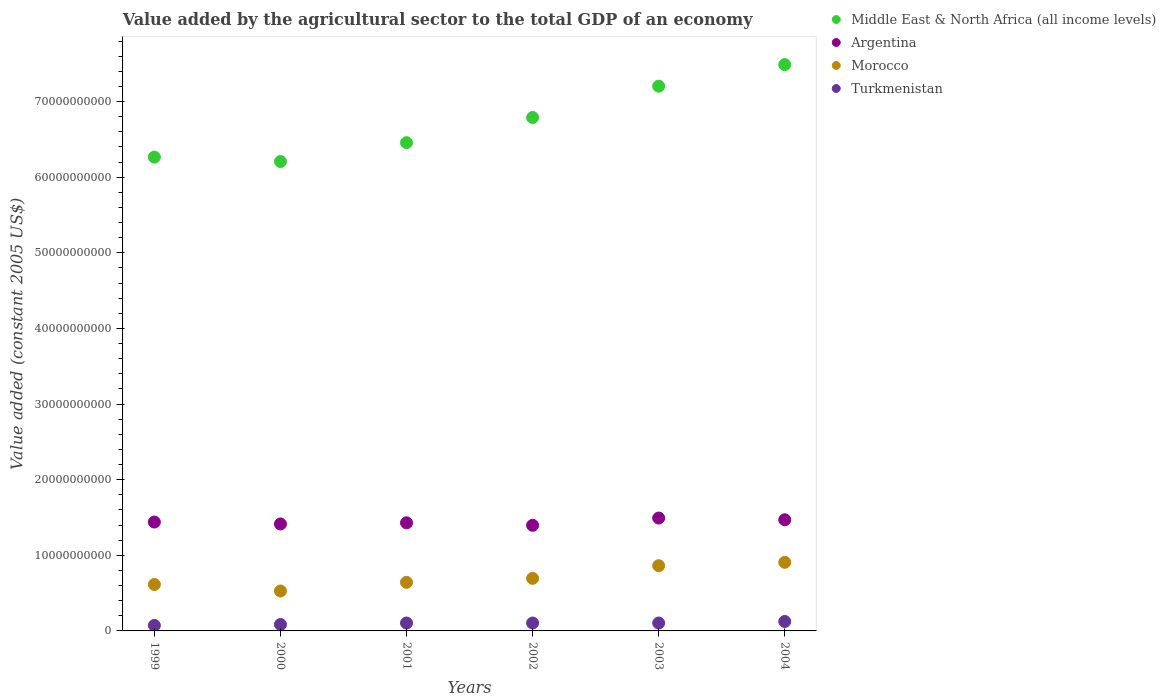Is the number of dotlines equal to the number of legend labels?
Offer a terse response. Yes. What is the value added by the agricultural sector in Morocco in 2003?
Keep it short and to the point. 8.62e+09. Across all years, what is the maximum value added by the agricultural sector in Middle East & North Africa (all income levels)?
Offer a very short reply. 7.49e+1. Across all years, what is the minimum value added by the agricultural sector in Turkmenistan?
Make the answer very short. 7.26e+08. In which year was the value added by the agricultural sector in Middle East & North Africa (all income levels) maximum?
Offer a very short reply. 2004. What is the total value added by the agricultural sector in Argentina in the graph?
Offer a very short reply. 8.64e+1. What is the difference between the value added by the agricultural sector in Turkmenistan in 1999 and that in 2000?
Your answer should be very brief. -1.23e+08. What is the difference between the value added by the agricultural sector in Morocco in 2002 and the value added by the agricultural sector in Turkmenistan in 1999?
Your response must be concise. 6.22e+09. What is the average value added by the agricultural sector in Turkmenistan per year?
Keep it short and to the point. 9.93e+08. In the year 2000, what is the difference between the value added by the agricultural sector in Turkmenistan and value added by the agricultural sector in Morocco?
Provide a succinct answer. -4.43e+09. In how many years, is the value added by the agricultural sector in Middle East & North Africa (all income levels) greater than 68000000000 US$?
Offer a very short reply. 2. What is the ratio of the value added by the agricultural sector in Morocco in 2000 to that in 2003?
Provide a succinct answer. 0.61. Is the value added by the agricultural sector in Argentina in 2000 less than that in 2004?
Your answer should be very brief. Yes. What is the difference between the highest and the second highest value added by the agricultural sector in Argentina?
Give a very brief answer. 2.28e+08. What is the difference between the highest and the lowest value added by the agricultural sector in Morocco?
Offer a terse response. 3.79e+09. In how many years, is the value added by the agricultural sector in Turkmenistan greater than the average value added by the agricultural sector in Turkmenistan taken over all years?
Your answer should be compact. 4. Is it the case that in every year, the sum of the value added by the agricultural sector in Middle East & North Africa (all income levels) and value added by the agricultural sector in Argentina  is greater than the value added by the agricultural sector in Turkmenistan?
Keep it short and to the point. Yes. Does the value added by the agricultural sector in Morocco monotonically increase over the years?
Offer a terse response. No. Is the value added by the agricultural sector in Argentina strictly less than the value added by the agricultural sector in Turkmenistan over the years?
Give a very brief answer. No. How many years are there in the graph?
Offer a very short reply. 6. Does the graph contain grids?
Keep it short and to the point. No. How are the legend labels stacked?
Offer a terse response. Vertical. What is the title of the graph?
Give a very brief answer. Value added by the agricultural sector to the total GDP of an economy. What is the label or title of the Y-axis?
Your answer should be compact. Value added (constant 2005 US$). What is the Value added (constant 2005 US$) in Middle East & North Africa (all income levels) in 1999?
Ensure brevity in your answer.  6.26e+1. What is the Value added (constant 2005 US$) in Argentina in 1999?
Provide a succinct answer. 1.44e+1. What is the Value added (constant 2005 US$) of Morocco in 1999?
Offer a terse response. 6.14e+09. What is the Value added (constant 2005 US$) of Turkmenistan in 1999?
Offer a very short reply. 7.26e+08. What is the Value added (constant 2005 US$) of Middle East & North Africa (all income levels) in 2000?
Provide a short and direct response. 6.21e+1. What is the Value added (constant 2005 US$) of Argentina in 2000?
Keep it short and to the point. 1.41e+1. What is the Value added (constant 2005 US$) in Morocco in 2000?
Keep it short and to the point. 5.28e+09. What is the Value added (constant 2005 US$) of Turkmenistan in 2000?
Make the answer very short. 8.49e+08. What is the Value added (constant 2005 US$) of Middle East & North Africa (all income levels) in 2001?
Give a very brief answer. 6.46e+1. What is the Value added (constant 2005 US$) of Argentina in 2001?
Keep it short and to the point. 1.43e+1. What is the Value added (constant 2005 US$) of Morocco in 2001?
Ensure brevity in your answer.  6.42e+09. What is the Value added (constant 2005 US$) of Turkmenistan in 2001?
Offer a very short reply. 1.04e+09. What is the Value added (constant 2005 US$) of Middle East & North Africa (all income levels) in 2002?
Provide a succinct answer. 6.79e+1. What is the Value added (constant 2005 US$) in Argentina in 2002?
Ensure brevity in your answer.  1.40e+1. What is the Value added (constant 2005 US$) of Morocco in 2002?
Offer a terse response. 6.95e+09. What is the Value added (constant 2005 US$) in Turkmenistan in 2002?
Your response must be concise. 1.05e+09. What is the Value added (constant 2005 US$) of Middle East & North Africa (all income levels) in 2003?
Your answer should be compact. 7.20e+1. What is the Value added (constant 2005 US$) in Argentina in 2003?
Keep it short and to the point. 1.49e+1. What is the Value added (constant 2005 US$) in Morocco in 2003?
Your answer should be very brief. 8.62e+09. What is the Value added (constant 2005 US$) in Turkmenistan in 2003?
Offer a very short reply. 1.05e+09. What is the Value added (constant 2005 US$) in Middle East & North Africa (all income levels) in 2004?
Offer a terse response. 7.49e+1. What is the Value added (constant 2005 US$) in Argentina in 2004?
Ensure brevity in your answer.  1.47e+1. What is the Value added (constant 2005 US$) in Morocco in 2004?
Provide a short and direct response. 9.07e+09. What is the Value added (constant 2005 US$) of Turkmenistan in 2004?
Make the answer very short. 1.25e+09. Across all years, what is the maximum Value added (constant 2005 US$) in Middle East & North Africa (all income levels)?
Provide a short and direct response. 7.49e+1. Across all years, what is the maximum Value added (constant 2005 US$) in Argentina?
Your response must be concise. 1.49e+1. Across all years, what is the maximum Value added (constant 2005 US$) in Morocco?
Offer a terse response. 9.07e+09. Across all years, what is the maximum Value added (constant 2005 US$) of Turkmenistan?
Offer a very short reply. 1.25e+09. Across all years, what is the minimum Value added (constant 2005 US$) in Middle East & North Africa (all income levels)?
Your answer should be compact. 6.21e+1. Across all years, what is the minimum Value added (constant 2005 US$) in Argentina?
Offer a very short reply. 1.40e+1. Across all years, what is the minimum Value added (constant 2005 US$) of Morocco?
Give a very brief answer. 5.28e+09. Across all years, what is the minimum Value added (constant 2005 US$) of Turkmenistan?
Your answer should be compact. 7.26e+08. What is the total Value added (constant 2005 US$) in Middle East & North Africa (all income levels) in the graph?
Provide a short and direct response. 4.04e+11. What is the total Value added (constant 2005 US$) in Argentina in the graph?
Offer a terse response. 8.64e+1. What is the total Value added (constant 2005 US$) in Morocco in the graph?
Your answer should be compact. 4.25e+1. What is the total Value added (constant 2005 US$) in Turkmenistan in the graph?
Keep it short and to the point. 5.96e+09. What is the difference between the Value added (constant 2005 US$) of Middle East & North Africa (all income levels) in 1999 and that in 2000?
Provide a succinct answer. 5.78e+08. What is the difference between the Value added (constant 2005 US$) in Argentina in 1999 and that in 2000?
Provide a short and direct response. 2.53e+08. What is the difference between the Value added (constant 2005 US$) in Morocco in 1999 and that in 2000?
Your answer should be very brief. 8.59e+08. What is the difference between the Value added (constant 2005 US$) in Turkmenistan in 1999 and that in 2000?
Provide a short and direct response. -1.23e+08. What is the difference between the Value added (constant 2005 US$) in Middle East & North Africa (all income levels) in 1999 and that in 2001?
Your response must be concise. -1.91e+09. What is the difference between the Value added (constant 2005 US$) of Argentina in 1999 and that in 2001?
Offer a very short reply. 1.04e+08. What is the difference between the Value added (constant 2005 US$) in Morocco in 1999 and that in 2001?
Make the answer very short. -2.87e+08. What is the difference between the Value added (constant 2005 US$) of Turkmenistan in 1999 and that in 2001?
Your response must be concise. -3.19e+08. What is the difference between the Value added (constant 2005 US$) of Middle East & North Africa (all income levels) in 1999 and that in 2002?
Your answer should be compact. -5.24e+09. What is the difference between the Value added (constant 2005 US$) in Argentina in 1999 and that in 2002?
Keep it short and to the point. 4.30e+08. What is the difference between the Value added (constant 2005 US$) in Morocco in 1999 and that in 2002?
Your answer should be compact. -8.09e+08. What is the difference between the Value added (constant 2005 US$) of Turkmenistan in 1999 and that in 2002?
Provide a succinct answer. -3.20e+08. What is the difference between the Value added (constant 2005 US$) of Middle East & North Africa (all income levels) in 1999 and that in 2003?
Provide a short and direct response. -9.38e+09. What is the difference between the Value added (constant 2005 US$) in Argentina in 1999 and that in 2003?
Provide a succinct answer. -5.29e+08. What is the difference between the Value added (constant 2005 US$) of Morocco in 1999 and that in 2003?
Ensure brevity in your answer.  -2.48e+09. What is the difference between the Value added (constant 2005 US$) of Turkmenistan in 1999 and that in 2003?
Ensure brevity in your answer.  -3.21e+08. What is the difference between the Value added (constant 2005 US$) of Middle East & North Africa (all income levels) in 1999 and that in 2004?
Give a very brief answer. -1.22e+1. What is the difference between the Value added (constant 2005 US$) of Argentina in 1999 and that in 2004?
Keep it short and to the point. -3.01e+08. What is the difference between the Value added (constant 2005 US$) in Morocco in 1999 and that in 2004?
Offer a terse response. -2.93e+09. What is the difference between the Value added (constant 2005 US$) of Turkmenistan in 1999 and that in 2004?
Ensure brevity in your answer.  -5.23e+08. What is the difference between the Value added (constant 2005 US$) of Middle East & North Africa (all income levels) in 2000 and that in 2001?
Your answer should be compact. -2.49e+09. What is the difference between the Value added (constant 2005 US$) in Argentina in 2000 and that in 2001?
Provide a succinct answer. -1.49e+08. What is the difference between the Value added (constant 2005 US$) of Morocco in 2000 and that in 2001?
Your answer should be very brief. -1.15e+09. What is the difference between the Value added (constant 2005 US$) of Turkmenistan in 2000 and that in 2001?
Give a very brief answer. -1.95e+08. What is the difference between the Value added (constant 2005 US$) of Middle East & North Africa (all income levels) in 2000 and that in 2002?
Provide a short and direct response. -5.82e+09. What is the difference between the Value added (constant 2005 US$) of Argentina in 2000 and that in 2002?
Give a very brief answer. 1.78e+08. What is the difference between the Value added (constant 2005 US$) in Morocco in 2000 and that in 2002?
Provide a succinct answer. -1.67e+09. What is the difference between the Value added (constant 2005 US$) in Turkmenistan in 2000 and that in 2002?
Offer a terse response. -1.96e+08. What is the difference between the Value added (constant 2005 US$) of Middle East & North Africa (all income levels) in 2000 and that in 2003?
Offer a very short reply. -9.96e+09. What is the difference between the Value added (constant 2005 US$) of Argentina in 2000 and that in 2003?
Keep it short and to the point. -7.82e+08. What is the difference between the Value added (constant 2005 US$) in Morocco in 2000 and that in 2003?
Provide a succinct answer. -3.34e+09. What is the difference between the Value added (constant 2005 US$) of Turkmenistan in 2000 and that in 2003?
Your response must be concise. -1.97e+08. What is the difference between the Value added (constant 2005 US$) of Middle East & North Africa (all income levels) in 2000 and that in 2004?
Offer a very short reply. -1.28e+1. What is the difference between the Value added (constant 2005 US$) in Argentina in 2000 and that in 2004?
Offer a very short reply. -5.54e+08. What is the difference between the Value added (constant 2005 US$) of Morocco in 2000 and that in 2004?
Your answer should be very brief. -3.79e+09. What is the difference between the Value added (constant 2005 US$) in Turkmenistan in 2000 and that in 2004?
Your answer should be compact. -3.99e+08. What is the difference between the Value added (constant 2005 US$) in Middle East & North Africa (all income levels) in 2001 and that in 2002?
Provide a succinct answer. -3.33e+09. What is the difference between the Value added (constant 2005 US$) of Argentina in 2001 and that in 2002?
Ensure brevity in your answer.  3.27e+08. What is the difference between the Value added (constant 2005 US$) of Morocco in 2001 and that in 2002?
Your response must be concise. -5.23e+08. What is the difference between the Value added (constant 2005 US$) of Turkmenistan in 2001 and that in 2002?
Provide a short and direct response. -9.92e+05. What is the difference between the Value added (constant 2005 US$) in Middle East & North Africa (all income levels) in 2001 and that in 2003?
Offer a terse response. -7.47e+09. What is the difference between the Value added (constant 2005 US$) in Argentina in 2001 and that in 2003?
Offer a very short reply. -6.33e+08. What is the difference between the Value added (constant 2005 US$) in Morocco in 2001 and that in 2003?
Your answer should be very brief. -2.20e+09. What is the difference between the Value added (constant 2005 US$) in Turkmenistan in 2001 and that in 2003?
Make the answer very short. -2.03e+06. What is the difference between the Value added (constant 2005 US$) of Middle East & North Africa (all income levels) in 2001 and that in 2004?
Provide a short and direct response. -1.03e+1. What is the difference between the Value added (constant 2005 US$) in Argentina in 2001 and that in 2004?
Keep it short and to the point. -4.05e+08. What is the difference between the Value added (constant 2005 US$) of Morocco in 2001 and that in 2004?
Provide a short and direct response. -2.65e+09. What is the difference between the Value added (constant 2005 US$) in Turkmenistan in 2001 and that in 2004?
Keep it short and to the point. -2.04e+08. What is the difference between the Value added (constant 2005 US$) of Middle East & North Africa (all income levels) in 2002 and that in 2003?
Keep it short and to the point. -4.14e+09. What is the difference between the Value added (constant 2005 US$) in Argentina in 2002 and that in 2003?
Give a very brief answer. -9.60e+08. What is the difference between the Value added (constant 2005 US$) in Morocco in 2002 and that in 2003?
Keep it short and to the point. -1.67e+09. What is the difference between the Value added (constant 2005 US$) of Turkmenistan in 2002 and that in 2003?
Provide a succinct answer. -1.03e+06. What is the difference between the Value added (constant 2005 US$) in Middle East & North Africa (all income levels) in 2002 and that in 2004?
Provide a short and direct response. -6.99e+09. What is the difference between the Value added (constant 2005 US$) of Argentina in 2002 and that in 2004?
Ensure brevity in your answer.  -7.32e+08. What is the difference between the Value added (constant 2005 US$) in Morocco in 2002 and that in 2004?
Offer a very short reply. -2.12e+09. What is the difference between the Value added (constant 2005 US$) in Turkmenistan in 2002 and that in 2004?
Your response must be concise. -2.03e+08. What is the difference between the Value added (constant 2005 US$) in Middle East & North Africa (all income levels) in 2003 and that in 2004?
Ensure brevity in your answer.  -2.85e+09. What is the difference between the Value added (constant 2005 US$) of Argentina in 2003 and that in 2004?
Your answer should be very brief. 2.28e+08. What is the difference between the Value added (constant 2005 US$) in Morocco in 2003 and that in 2004?
Provide a succinct answer. -4.49e+08. What is the difference between the Value added (constant 2005 US$) in Turkmenistan in 2003 and that in 2004?
Offer a very short reply. -2.02e+08. What is the difference between the Value added (constant 2005 US$) of Middle East & North Africa (all income levels) in 1999 and the Value added (constant 2005 US$) of Argentina in 2000?
Provide a succinct answer. 4.85e+1. What is the difference between the Value added (constant 2005 US$) of Middle East & North Africa (all income levels) in 1999 and the Value added (constant 2005 US$) of Morocco in 2000?
Keep it short and to the point. 5.74e+1. What is the difference between the Value added (constant 2005 US$) in Middle East & North Africa (all income levels) in 1999 and the Value added (constant 2005 US$) in Turkmenistan in 2000?
Your response must be concise. 6.18e+1. What is the difference between the Value added (constant 2005 US$) of Argentina in 1999 and the Value added (constant 2005 US$) of Morocco in 2000?
Ensure brevity in your answer.  9.12e+09. What is the difference between the Value added (constant 2005 US$) of Argentina in 1999 and the Value added (constant 2005 US$) of Turkmenistan in 2000?
Provide a succinct answer. 1.35e+1. What is the difference between the Value added (constant 2005 US$) of Morocco in 1999 and the Value added (constant 2005 US$) of Turkmenistan in 2000?
Provide a short and direct response. 5.29e+09. What is the difference between the Value added (constant 2005 US$) of Middle East & North Africa (all income levels) in 1999 and the Value added (constant 2005 US$) of Argentina in 2001?
Your answer should be very brief. 4.84e+1. What is the difference between the Value added (constant 2005 US$) of Middle East & North Africa (all income levels) in 1999 and the Value added (constant 2005 US$) of Morocco in 2001?
Offer a very short reply. 5.62e+1. What is the difference between the Value added (constant 2005 US$) in Middle East & North Africa (all income levels) in 1999 and the Value added (constant 2005 US$) in Turkmenistan in 2001?
Provide a succinct answer. 6.16e+1. What is the difference between the Value added (constant 2005 US$) of Argentina in 1999 and the Value added (constant 2005 US$) of Morocco in 2001?
Offer a terse response. 7.97e+09. What is the difference between the Value added (constant 2005 US$) in Argentina in 1999 and the Value added (constant 2005 US$) in Turkmenistan in 2001?
Your answer should be compact. 1.34e+1. What is the difference between the Value added (constant 2005 US$) of Morocco in 1999 and the Value added (constant 2005 US$) of Turkmenistan in 2001?
Offer a very short reply. 5.09e+09. What is the difference between the Value added (constant 2005 US$) of Middle East & North Africa (all income levels) in 1999 and the Value added (constant 2005 US$) of Argentina in 2002?
Your answer should be compact. 4.87e+1. What is the difference between the Value added (constant 2005 US$) in Middle East & North Africa (all income levels) in 1999 and the Value added (constant 2005 US$) in Morocco in 2002?
Your answer should be very brief. 5.57e+1. What is the difference between the Value added (constant 2005 US$) in Middle East & North Africa (all income levels) in 1999 and the Value added (constant 2005 US$) in Turkmenistan in 2002?
Your answer should be very brief. 6.16e+1. What is the difference between the Value added (constant 2005 US$) of Argentina in 1999 and the Value added (constant 2005 US$) of Morocco in 2002?
Give a very brief answer. 7.45e+09. What is the difference between the Value added (constant 2005 US$) of Argentina in 1999 and the Value added (constant 2005 US$) of Turkmenistan in 2002?
Provide a succinct answer. 1.34e+1. What is the difference between the Value added (constant 2005 US$) of Morocco in 1999 and the Value added (constant 2005 US$) of Turkmenistan in 2002?
Give a very brief answer. 5.09e+09. What is the difference between the Value added (constant 2005 US$) in Middle East & North Africa (all income levels) in 1999 and the Value added (constant 2005 US$) in Argentina in 2003?
Give a very brief answer. 4.77e+1. What is the difference between the Value added (constant 2005 US$) in Middle East & North Africa (all income levels) in 1999 and the Value added (constant 2005 US$) in Morocco in 2003?
Provide a short and direct response. 5.40e+1. What is the difference between the Value added (constant 2005 US$) in Middle East & North Africa (all income levels) in 1999 and the Value added (constant 2005 US$) in Turkmenistan in 2003?
Make the answer very short. 6.16e+1. What is the difference between the Value added (constant 2005 US$) of Argentina in 1999 and the Value added (constant 2005 US$) of Morocco in 2003?
Provide a succinct answer. 5.78e+09. What is the difference between the Value added (constant 2005 US$) of Argentina in 1999 and the Value added (constant 2005 US$) of Turkmenistan in 2003?
Give a very brief answer. 1.34e+1. What is the difference between the Value added (constant 2005 US$) of Morocco in 1999 and the Value added (constant 2005 US$) of Turkmenistan in 2003?
Your answer should be compact. 5.09e+09. What is the difference between the Value added (constant 2005 US$) of Middle East & North Africa (all income levels) in 1999 and the Value added (constant 2005 US$) of Argentina in 2004?
Provide a succinct answer. 4.80e+1. What is the difference between the Value added (constant 2005 US$) of Middle East & North Africa (all income levels) in 1999 and the Value added (constant 2005 US$) of Morocco in 2004?
Make the answer very short. 5.36e+1. What is the difference between the Value added (constant 2005 US$) in Middle East & North Africa (all income levels) in 1999 and the Value added (constant 2005 US$) in Turkmenistan in 2004?
Your answer should be compact. 6.14e+1. What is the difference between the Value added (constant 2005 US$) in Argentina in 1999 and the Value added (constant 2005 US$) in Morocco in 2004?
Provide a short and direct response. 5.33e+09. What is the difference between the Value added (constant 2005 US$) of Argentina in 1999 and the Value added (constant 2005 US$) of Turkmenistan in 2004?
Make the answer very short. 1.31e+1. What is the difference between the Value added (constant 2005 US$) of Morocco in 1999 and the Value added (constant 2005 US$) of Turkmenistan in 2004?
Make the answer very short. 4.89e+09. What is the difference between the Value added (constant 2005 US$) of Middle East & North Africa (all income levels) in 2000 and the Value added (constant 2005 US$) of Argentina in 2001?
Your answer should be compact. 4.78e+1. What is the difference between the Value added (constant 2005 US$) of Middle East & North Africa (all income levels) in 2000 and the Value added (constant 2005 US$) of Morocco in 2001?
Provide a short and direct response. 5.56e+1. What is the difference between the Value added (constant 2005 US$) in Middle East & North Africa (all income levels) in 2000 and the Value added (constant 2005 US$) in Turkmenistan in 2001?
Make the answer very short. 6.10e+1. What is the difference between the Value added (constant 2005 US$) in Argentina in 2000 and the Value added (constant 2005 US$) in Morocco in 2001?
Ensure brevity in your answer.  7.72e+09. What is the difference between the Value added (constant 2005 US$) in Argentina in 2000 and the Value added (constant 2005 US$) in Turkmenistan in 2001?
Your answer should be very brief. 1.31e+1. What is the difference between the Value added (constant 2005 US$) in Morocco in 2000 and the Value added (constant 2005 US$) in Turkmenistan in 2001?
Make the answer very short. 4.23e+09. What is the difference between the Value added (constant 2005 US$) in Middle East & North Africa (all income levels) in 2000 and the Value added (constant 2005 US$) in Argentina in 2002?
Your answer should be very brief. 4.81e+1. What is the difference between the Value added (constant 2005 US$) in Middle East & North Africa (all income levels) in 2000 and the Value added (constant 2005 US$) in Morocco in 2002?
Offer a very short reply. 5.51e+1. What is the difference between the Value added (constant 2005 US$) in Middle East & North Africa (all income levels) in 2000 and the Value added (constant 2005 US$) in Turkmenistan in 2002?
Make the answer very short. 6.10e+1. What is the difference between the Value added (constant 2005 US$) of Argentina in 2000 and the Value added (constant 2005 US$) of Morocco in 2002?
Provide a short and direct response. 7.20e+09. What is the difference between the Value added (constant 2005 US$) of Argentina in 2000 and the Value added (constant 2005 US$) of Turkmenistan in 2002?
Provide a short and direct response. 1.31e+1. What is the difference between the Value added (constant 2005 US$) of Morocco in 2000 and the Value added (constant 2005 US$) of Turkmenistan in 2002?
Your response must be concise. 4.23e+09. What is the difference between the Value added (constant 2005 US$) of Middle East & North Africa (all income levels) in 2000 and the Value added (constant 2005 US$) of Argentina in 2003?
Make the answer very short. 4.71e+1. What is the difference between the Value added (constant 2005 US$) in Middle East & North Africa (all income levels) in 2000 and the Value added (constant 2005 US$) in Morocco in 2003?
Provide a succinct answer. 5.34e+1. What is the difference between the Value added (constant 2005 US$) of Middle East & North Africa (all income levels) in 2000 and the Value added (constant 2005 US$) of Turkmenistan in 2003?
Your answer should be compact. 6.10e+1. What is the difference between the Value added (constant 2005 US$) in Argentina in 2000 and the Value added (constant 2005 US$) in Morocco in 2003?
Your answer should be compact. 5.52e+09. What is the difference between the Value added (constant 2005 US$) in Argentina in 2000 and the Value added (constant 2005 US$) in Turkmenistan in 2003?
Your response must be concise. 1.31e+1. What is the difference between the Value added (constant 2005 US$) of Morocco in 2000 and the Value added (constant 2005 US$) of Turkmenistan in 2003?
Your answer should be compact. 4.23e+09. What is the difference between the Value added (constant 2005 US$) of Middle East & North Africa (all income levels) in 2000 and the Value added (constant 2005 US$) of Argentina in 2004?
Give a very brief answer. 4.74e+1. What is the difference between the Value added (constant 2005 US$) of Middle East & North Africa (all income levels) in 2000 and the Value added (constant 2005 US$) of Morocco in 2004?
Offer a very short reply. 5.30e+1. What is the difference between the Value added (constant 2005 US$) in Middle East & North Africa (all income levels) in 2000 and the Value added (constant 2005 US$) in Turkmenistan in 2004?
Keep it short and to the point. 6.08e+1. What is the difference between the Value added (constant 2005 US$) in Argentina in 2000 and the Value added (constant 2005 US$) in Morocco in 2004?
Offer a very short reply. 5.07e+09. What is the difference between the Value added (constant 2005 US$) in Argentina in 2000 and the Value added (constant 2005 US$) in Turkmenistan in 2004?
Give a very brief answer. 1.29e+1. What is the difference between the Value added (constant 2005 US$) in Morocco in 2000 and the Value added (constant 2005 US$) in Turkmenistan in 2004?
Your response must be concise. 4.03e+09. What is the difference between the Value added (constant 2005 US$) of Middle East & North Africa (all income levels) in 2001 and the Value added (constant 2005 US$) of Argentina in 2002?
Make the answer very short. 5.06e+1. What is the difference between the Value added (constant 2005 US$) in Middle East & North Africa (all income levels) in 2001 and the Value added (constant 2005 US$) in Morocco in 2002?
Keep it short and to the point. 5.76e+1. What is the difference between the Value added (constant 2005 US$) of Middle East & North Africa (all income levels) in 2001 and the Value added (constant 2005 US$) of Turkmenistan in 2002?
Ensure brevity in your answer.  6.35e+1. What is the difference between the Value added (constant 2005 US$) of Argentina in 2001 and the Value added (constant 2005 US$) of Morocco in 2002?
Offer a terse response. 7.35e+09. What is the difference between the Value added (constant 2005 US$) of Argentina in 2001 and the Value added (constant 2005 US$) of Turkmenistan in 2002?
Offer a terse response. 1.32e+1. What is the difference between the Value added (constant 2005 US$) of Morocco in 2001 and the Value added (constant 2005 US$) of Turkmenistan in 2002?
Keep it short and to the point. 5.38e+09. What is the difference between the Value added (constant 2005 US$) in Middle East & North Africa (all income levels) in 2001 and the Value added (constant 2005 US$) in Argentina in 2003?
Your answer should be very brief. 4.96e+1. What is the difference between the Value added (constant 2005 US$) in Middle East & North Africa (all income levels) in 2001 and the Value added (constant 2005 US$) in Morocco in 2003?
Offer a very short reply. 5.59e+1. What is the difference between the Value added (constant 2005 US$) of Middle East & North Africa (all income levels) in 2001 and the Value added (constant 2005 US$) of Turkmenistan in 2003?
Your answer should be very brief. 6.35e+1. What is the difference between the Value added (constant 2005 US$) of Argentina in 2001 and the Value added (constant 2005 US$) of Morocco in 2003?
Offer a terse response. 5.67e+09. What is the difference between the Value added (constant 2005 US$) of Argentina in 2001 and the Value added (constant 2005 US$) of Turkmenistan in 2003?
Your answer should be very brief. 1.32e+1. What is the difference between the Value added (constant 2005 US$) in Morocco in 2001 and the Value added (constant 2005 US$) in Turkmenistan in 2003?
Your answer should be compact. 5.38e+09. What is the difference between the Value added (constant 2005 US$) in Middle East & North Africa (all income levels) in 2001 and the Value added (constant 2005 US$) in Argentina in 2004?
Make the answer very short. 4.99e+1. What is the difference between the Value added (constant 2005 US$) in Middle East & North Africa (all income levels) in 2001 and the Value added (constant 2005 US$) in Morocco in 2004?
Your answer should be compact. 5.55e+1. What is the difference between the Value added (constant 2005 US$) of Middle East & North Africa (all income levels) in 2001 and the Value added (constant 2005 US$) of Turkmenistan in 2004?
Your answer should be compact. 6.33e+1. What is the difference between the Value added (constant 2005 US$) in Argentina in 2001 and the Value added (constant 2005 US$) in Morocco in 2004?
Your answer should be compact. 5.22e+09. What is the difference between the Value added (constant 2005 US$) of Argentina in 2001 and the Value added (constant 2005 US$) of Turkmenistan in 2004?
Provide a short and direct response. 1.30e+1. What is the difference between the Value added (constant 2005 US$) of Morocco in 2001 and the Value added (constant 2005 US$) of Turkmenistan in 2004?
Give a very brief answer. 5.18e+09. What is the difference between the Value added (constant 2005 US$) in Middle East & North Africa (all income levels) in 2002 and the Value added (constant 2005 US$) in Argentina in 2003?
Your answer should be very brief. 5.30e+1. What is the difference between the Value added (constant 2005 US$) in Middle East & North Africa (all income levels) in 2002 and the Value added (constant 2005 US$) in Morocco in 2003?
Ensure brevity in your answer.  5.93e+1. What is the difference between the Value added (constant 2005 US$) in Middle East & North Africa (all income levels) in 2002 and the Value added (constant 2005 US$) in Turkmenistan in 2003?
Keep it short and to the point. 6.68e+1. What is the difference between the Value added (constant 2005 US$) of Argentina in 2002 and the Value added (constant 2005 US$) of Morocco in 2003?
Offer a very short reply. 5.35e+09. What is the difference between the Value added (constant 2005 US$) in Argentina in 2002 and the Value added (constant 2005 US$) in Turkmenistan in 2003?
Your response must be concise. 1.29e+1. What is the difference between the Value added (constant 2005 US$) in Morocco in 2002 and the Value added (constant 2005 US$) in Turkmenistan in 2003?
Provide a succinct answer. 5.90e+09. What is the difference between the Value added (constant 2005 US$) of Middle East & North Africa (all income levels) in 2002 and the Value added (constant 2005 US$) of Argentina in 2004?
Give a very brief answer. 5.32e+1. What is the difference between the Value added (constant 2005 US$) in Middle East & North Africa (all income levels) in 2002 and the Value added (constant 2005 US$) in Morocco in 2004?
Give a very brief answer. 5.88e+1. What is the difference between the Value added (constant 2005 US$) in Middle East & North Africa (all income levels) in 2002 and the Value added (constant 2005 US$) in Turkmenistan in 2004?
Your answer should be very brief. 6.66e+1. What is the difference between the Value added (constant 2005 US$) in Argentina in 2002 and the Value added (constant 2005 US$) in Morocco in 2004?
Offer a terse response. 4.90e+09. What is the difference between the Value added (constant 2005 US$) in Argentina in 2002 and the Value added (constant 2005 US$) in Turkmenistan in 2004?
Your answer should be very brief. 1.27e+1. What is the difference between the Value added (constant 2005 US$) in Morocco in 2002 and the Value added (constant 2005 US$) in Turkmenistan in 2004?
Give a very brief answer. 5.70e+09. What is the difference between the Value added (constant 2005 US$) of Middle East & North Africa (all income levels) in 2003 and the Value added (constant 2005 US$) of Argentina in 2004?
Offer a very short reply. 5.73e+1. What is the difference between the Value added (constant 2005 US$) of Middle East & North Africa (all income levels) in 2003 and the Value added (constant 2005 US$) of Morocco in 2004?
Your response must be concise. 6.30e+1. What is the difference between the Value added (constant 2005 US$) of Middle East & North Africa (all income levels) in 2003 and the Value added (constant 2005 US$) of Turkmenistan in 2004?
Keep it short and to the point. 7.08e+1. What is the difference between the Value added (constant 2005 US$) in Argentina in 2003 and the Value added (constant 2005 US$) in Morocco in 2004?
Your response must be concise. 5.86e+09. What is the difference between the Value added (constant 2005 US$) of Argentina in 2003 and the Value added (constant 2005 US$) of Turkmenistan in 2004?
Your answer should be compact. 1.37e+1. What is the difference between the Value added (constant 2005 US$) in Morocco in 2003 and the Value added (constant 2005 US$) in Turkmenistan in 2004?
Keep it short and to the point. 7.37e+09. What is the average Value added (constant 2005 US$) in Middle East & North Africa (all income levels) per year?
Ensure brevity in your answer.  6.73e+1. What is the average Value added (constant 2005 US$) in Argentina per year?
Make the answer very short. 1.44e+1. What is the average Value added (constant 2005 US$) of Morocco per year?
Give a very brief answer. 7.08e+09. What is the average Value added (constant 2005 US$) in Turkmenistan per year?
Ensure brevity in your answer.  9.93e+08. In the year 1999, what is the difference between the Value added (constant 2005 US$) in Middle East & North Africa (all income levels) and Value added (constant 2005 US$) in Argentina?
Your answer should be compact. 4.83e+1. In the year 1999, what is the difference between the Value added (constant 2005 US$) of Middle East & North Africa (all income levels) and Value added (constant 2005 US$) of Morocco?
Ensure brevity in your answer.  5.65e+1. In the year 1999, what is the difference between the Value added (constant 2005 US$) of Middle East & North Africa (all income levels) and Value added (constant 2005 US$) of Turkmenistan?
Ensure brevity in your answer.  6.19e+1. In the year 1999, what is the difference between the Value added (constant 2005 US$) of Argentina and Value added (constant 2005 US$) of Morocco?
Offer a very short reply. 8.26e+09. In the year 1999, what is the difference between the Value added (constant 2005 US$) in Argentina and Value added (constant 2005 US$) in Turkmenistan?
Offer a terse response. 1.37e+1. In the year 1999, what is the difference between the Value added (constant 2005 US$) in Morocco and Value added (constant 2005 US$) in Turkmenistan?
Offer a terse response. 5.41e+09. In the year 2000, what is the difference between the Value added (constant 2005 US$) in Middle East & North Africa (all income levels) and Value added (constant 2005 US$) in Argentina?
Your answer should be very brief. 4.79e+1. In the year 2000, what is the difference between the Value added (constant 2005 US$) in Middle East & North Africa (all income levels) and Value added (constant 2005 US$) in Morocco?
Your answer should be very brief. 5.68e+1. In the year 2000, what is the difference between the Value added (constant 2005 US$) of Middle East & North Africa (all income levels) and Value added (constant 2005 US$) of Turkmenistan?
Give a very brief answer. 6.12e+1. In the year 2000, what is the difference between the Value added (constant 2005 US$) in Argentina and Value added (constant 2005 US$) in Morocco?
Ensure brevity in your answer.  8.87e+09. In the year 2000, what is the difference between the Value added (constant 2005 US$) of Argentina and Value added (constant 2005 US$) of Turkmenistan?
Provide a short and direct response. 1.33e+1. In the year 2000, what is the difference between the Value added (constant 2005 US$) of Morocco and Value added (constant 2005 US$) of Turkmenistan?
Give a very brief answer. 4.43e+09. In the year 2001, what is the difference between the Value added (constant 2005 US$) of Middle East & North Africa (all income levels) and Value added (constant 2005 US$) of Argentina?
Your response must be concise. 5.03e+1. In the year 2001, what is the difference between the Value added (constant 2005 US$) of Middle East & North Africa (all income levels) and Value added (constant 2005 US$) of Morocco?
Give a very brief answer. 5.81e+1. In the year 2001, what is the difference between the Value added (constant 2005 US$) of Middle East & North Africa (all income levels) and Value added (constant 2005 US$) of Turkmenistan?
Offer a terse response. 6.35e+1. In the year 2001, what is the difference between the Value added (constant 2005 US$) in Argentina and Value added (constant 2005 US$) in Morocco?
Offer a terse response. 7.87e+09. In the year 2001, what is the difference between the Value added (constant 2005 US$) in Argentina and Value added (constant 2005 US$) in Turkmenistan?
Provide a short and direct response. 1.32e+1. In the year 2001, what is the difference between the Value added (constant 2005 US$) of Morocco and Value added (constant 2005 US$) of Turkmenistan?
Provide a short and direct response. 5.38e+09. In the year 2002, what is the difference between the Value added (constant 2005 US$) in Middle East & North Africa (all income levels) and Value added (constant 2005 US$) in Argentina?
Your answer should be compact. 5.39e+1. In the year 2002, what is the difference between the Value added (constant 2005 US$) of Middle East & North Africa (all income levels) and Value added (constant 2005 US$) of Morocco?
Provide a short and direct response. 6.09e+1. In the year 2002, what is the difference between the Value added (constant 2005 US$) in Middle East & North Africa (all income levels) and Value added (constant 2005 US$) in Turkmenistan?
Offer a terse response. 6.68e+1. In the year 2002, what is the difference between the Value added (constant 2005 US$) in Argentina and Value added (constant 2005 US$) in Morocco?
Your response must be concise. 7.02e+09. In the year 2002, what is the difference between the Value added (constant 2005 US$) in Argentina and Value added (constant 2005 US$) in Turkmenistan?
Your response must be concise. 1.29e+1. In the year 2002, what is the difference between the Value added (constant 2005 US$) in Morocco and Value added (constant 2005 US$) in Turkmenistan?
Offer a very short reply. 5.90e+09. In the year 2003, what is the difference between the Value added (constant 2005 US$) of Middle East & North Africa (all income levels) and Value added (constant 2005 US$) of Argentina?
Your answer should be very brief. 5.71e+1. In the year 2003, what is the difference between the Value added (constant 2005 US$) of Middle East & North Africa (all income levels) and Value added (constant 2005 US$) of Morocco?
Give a very brief answer. 6.34e+1. In the year 2003, what is the difference between the Value added (constant 2005 US$) in Middle East & North Africa (all income levels) and Value added (constant 2005 US$) in Turkmenistan?
Keep it short and to the point. 7.10e+1. In the year 2003, what is the difference between the Value added (constant 2005 US$) in Argentina and Value added (constant 2005 US$) in Morocco?
Keep it short and to the point. 6.31e+09. In the year 2003, what is the difference between the Value added (constant 2005 US$) of Argentina and Value added (constant 2005 US$) of Turkmenistan?
Give a very brief answer. 1.39e+1. In the year 2003, what is the difference between the Value added (constant 2005 US$) of Morocco and Value added (constant 2005 US$) of Turkmenistan?
Your answer should be very brief. 7.57e+09. In the year 2004, what is the difference between the Value added (constant 2005 US$) in Middle East & North Africa (all income levels) and Value added (constant 2005 US$) in Argentina?
Give a very brief answer. 6.02e+1. In the year 2004, what is the difference between the Value added (constant 2005 US$) in Middle East & North Africa (all income levels) and Value added (constant 2005 US$) in Morocco?
Offer a terse response. 6.58e+1. In the year 2004, what is the difference between the Value added (constant 2005 US$) of Middle East & North Africa (all income levels) and Value added (constant 2005 US$) of Turkmenistan?
Keep it short and to the point. 7.36e+1. In the year 2004, what is the difference between the Value added (constant 2005 US$) in Argentina and Value added (constant 2005 US$) in Morocco?
Ensure brevity in your answer.  5.63e+09. In the year 2004, what is the difference between the Value added (constant 2005 US$) of Argentina and Value added (constant 2005 US$) of Turkmenistan?
Your answer should be compact. 1.35e+1. In the year 2004, what is the difference between the Value added (constant 2005 US$) of Morocco and Value added (constant 2005 US$) of Turkmenistan?
Your answer should be very brief. 7.82e+09. What is the ratio of the Value added (constant 2005 US$) in Middle East & North Africa (all income levels) in 1999 to that in 2000?
Offer a very short reply. 1.01. What is the ratio of the Value added (constant 2005 US$) of Argentina in 1999 to that in 2000?
Your answer should be very brief. 1.02. What is the ratio of the Value added (constant 2005 US$) in Morocco in 1999 to that in 2000?
Keep it short and to the point. 1.16. What is the ratio of the Value added (constant 2005 US$) of Turkmenistan in 1999 to that in 2000?
Give a very brief answer. 0.85. What is the ratio of the Value added (constant 2005 US$) in Middle East & North Africa (all income levels) in 1999 to that in 2001?
Keep it short and to the point. 0.97. What is the ratio of the Value added (constant 2005 US$) of Argentina in 1999 to that in 2001?
Give a very brief answer. 1.01. What is the ratio of the Value added (constant 2005 US$) in Morocco in 1999 to that in 2001?
Provide a short and direct response. 0.96. What is the ratio of the Value added (constant 2005 US$) in Turkmenistan in 1999 to that in 2001?
Offer a terse response. 0.69. What is the ratio of the Value added (constant 2005 US$) of Middle East & North Africa (all income levels) in 1999 to that in 2002?
Ensure brevity in your answer.  0.92. What is the ratio of the Value added (constant 2005 US$) of Argentina in 1999 to that in 2002?
Ensure brevity in your answer.  1.03. What is the ratio of the Value added (constant 2005 US$) of Morocco in 1999 to that in 2002?
Keep it short and to the point. 0.88. What is the ratio of the Value added (constant 2005 US$) in Turkmenistan in 1999 to that in 2002?
Your answer should be compact. 0.69. What is the ratio of the Value added (constant 2005 US$) in Middle East & North Africa (all income levels) in 1999 to that in 2003?
Offer a terse response. 0.87. What is the ratio of the Value added (constant 2005 US$) in Argentina in 1999 to that in 2003?
Your answer should be compact. 0.96. What is the ratio of the Value added (constant 2005 US$) of Morocco in 1999 to that in 2003?
Provide a succinct answer. 0.71. What is the ratio of the Value added (constant 2005 US$) of Turkmenistan in 1999 to that in 2003?
Your answer should be very brief. 0.69. What is the ratio of the Value added (constant 2005 US$) in Middle East & North Africa (all income levels) in 1999 to that in 2004?
Ensure brevity in your answer.  0.84. What is the ratio of the Value added (constant 2005 US$) in Argentina in 1999 to that in 2004?
Your answer should be compact. 0.98. What is the ratio of the Value added (constant 2005 US$) in Morocco in 1999 to that in 2004?
Provide a succinct answer. 0.68. What is the ratio of the Value added (constant 2005 US$) of Turkmenistan in 1999 to that in 2004?
Your answer should be very brief. 0.58. What is the ratio of the Value added (constant 2005 US$) of Middle East & North Africa (all income levels) in 2000 to that in 2001?
Make the answer very short. 0.96. What is the ratio of the Value added (constant 2005 US$) of Argentina in 2000 to that in 2001?
Your response must be concise. 0.99. What is the ratio of the Value added (constant 2005 US$) of Morocco in 2000 to that in 2001?
Offer a very short reply. 0.82. What is the ratio of the Value added (constant 2005 US$) of Turkmenistan in 2000 to that in 2001?
Provide a succinct answer. 0.81. What is the ratio of the Value added (constant 2005 US$) in Middle East & North Africa (all income levels) in 2000 to that in 2002?
Ensure brevity in your answer.  0.91. What is the ratio of the Value added (constant 2005 US$) of Argentina in 2000 to that in 2002?
Keep it short and to the point. 1.01. What is the ratio of the Value added (constant 2005 US$) of Morocco in 2000 to that in 2002?
Give a very brief answer. 0.76. What is the ratio of the Value added (constant 2005 US$) of Turkmenistan in 2000 to that in 2002?
Offer a very short reply. 0.81. What is the ratio of the Value added (constant 2005 US$) in Middle East & North Africa (all income levels) in 2000 to that in 2003?
Offer a very short reply. 0.86. What is the ratio of the Value added (constant 2005 US$) of Argentina in 2000 to that in 2003?
Give a very brief answer. 0.95. What is the ratio of the Value added (constant 2005 US$) in Morocco in 2000 to that in 2003?
Offer a very short reply. 0.61. What is the ratio of the Value added (constant 2005 US$) in Turkmenistan in 2000 to that in 2003?
Your response must be concise. 0.81. What is the ratio of the Value added (constant 2005 US$) in Middle East & North Africa (all income levels) in 2000 to that in 2004?
Provide a short and direct response. 0.83. What is the ratio of the Value added (constant 2005 US$) in Argentina in 2000 to that in 2004?
Provide a succinct answer. 0.96. What is the ratio of the Value added (constant 2005 US$) in Morocco in 2000 to that in 2004?
Your answer should be very brief. 0.58. What is the ratio of the Value added (constant 2005 US$) of Turkmenistan in 2000 to that in 2004?
Give a very brief answer. 0.68. What is the ratio of the Value added (constant 2005 US$) in Middle East & North Africa (all income levels) in 2001 to that in 2002?
Offer a very short reply. 0.95. What is the ratio of the Value added (constant 2005 US$) in Argentina in 2001 to that in 2002?
Your answer should be very brief. 1.02. What is the ratio of the Value added (constant 2005 US$) in Morocco in 2001 to that in 2002?
Your answer should be compact. 0.92. What is the ratio of the Value added (constant 2005 US$) of Middle East & North Africa (all income levels) in 2001 to that in 2003?
Provide a succinct answer. 0.9. What is the ratio of the Value added (constant 2005 US$) of Argentina in 2001 to that in 2003?
Provide a succinct answer. 0.96. What is the ratio of the Value added (constant 2005 US$) of Morocco in 2001 to that in 2003?
Keep it short and to the point. 0.75. What is the ratio of the Value added (constant 2005 US$) in Middle East & North Africa (all income levels) in 2001 to that in 2004?
Offer a very short reply. 0.86. What is the ratio of the Value added (constant 2005 US$) of Argentina in 2001 to that in 2004?
Offer a terse response. 0.97. What is the ratio of the Value added (constant 2005 US$) in Morocco in 2001 to that in 2004?
Your answer should be compact. 0.71. What is the ratio of the Value added (constant 2005 US$) in Turkmenistan in 2001 to that in 2004?
Your answer should be compact. 0.84. What is the ratio of the Value added (constant 2005 US$) in Middle East & North Africa (all income levels) in 2002 to that in 2003?
Give a very brief answer. 0.94. What is the ratio of the Value added (constant 2005 US$) in Argentina in 2002 to that in 2003?
Keep it short and to the point. 0.94. What is the ratio of the Value added (constant 2005 US$) of Morocco in 2002 to that in 2003?
Your answer should be very brief. 0.81. What is the ratio of the Value added (constant 2005 US$) in Middle East & North Africa (all income levels) in 2002 to that in 2004?
Make the answer very short. 0.91. What is the ratio of the Value added (constant 2005 US$) in Argentina in 2002 to that in 2004?
Offer a very short reply. 0.95. What is the ratio of the Value added (constant 2005 US$) in Morocco in 2002 to that in 2004?
Give a very brief answer. 0.77. What is the ratio of the Value added (constant 2005 US$) of Turkmenistan in 2002 to that in 2004?
Ensure brevity in your answer.  0.84. What is the ratio of the Value added (constant 2005 US$) of Middle East & North Africa (all income levels) in 2003 to that in 2004?
Keep it short and to the point. 0.96. What is the ratio of the Value added (constant 2005 US$) of Argentina in 2003 to that in 2004?
Keep it short and to the point. 1.02. What is the ratio of the Value added (constant 2005 US$) of Morocco in 2003 to that in 2004?
Offer a terse response. 0.95. What is the ratio of the Value added (constant 2005 US$) of Turkmenistan in 2003 to that in 2004?
Make the answer very short. 0.84. What is the difference between the highest and the second highest Value added (constant 2005 US$) of Middle East & North Africa (all income levels)?
Your answer should be compact. 2.85e+09. What is the difference between the highest and the second highest Value added (constant 2005 US$) in Argentina?
Your response must be concise. 2.28e+08. What is the difference between the highest and the second highest Value added (constant 2005 US$) in Morocco?
Make the answer very short. 4.49e+08. What is the difference between the highest and the second highest Value added (constant 2005 US$) in Turkmenistan?
Your answer should be very brief. 2.02e+08. What is the difference between the highest and the lowest Value added (constant 2005 US$) in Middle East & North Africa (all income levels)?
Offer a terse response. 1.28e+1. What is the difference between the highest and the lowest Value added (constant 2005 US$) in Argentina?
Offer a terse response. 9.60e+08. What is the difference between the highest and the lowest Value added (constant 2005 US$) of Morocco?
Keep it short and to the point. 3.79e+09. What is the difference between the highest and the lowest Value added (constant 2005 US$) in Turkmenistan?
Provide a short and direct response. 5.23e+08. 